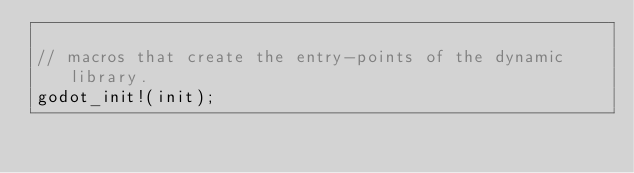<code> <loc_0><loc_0><loc_500><loc_500><_Rust_>
// macros that create the entry-points of the dynamic library.
godot_init!(init);
</code> 